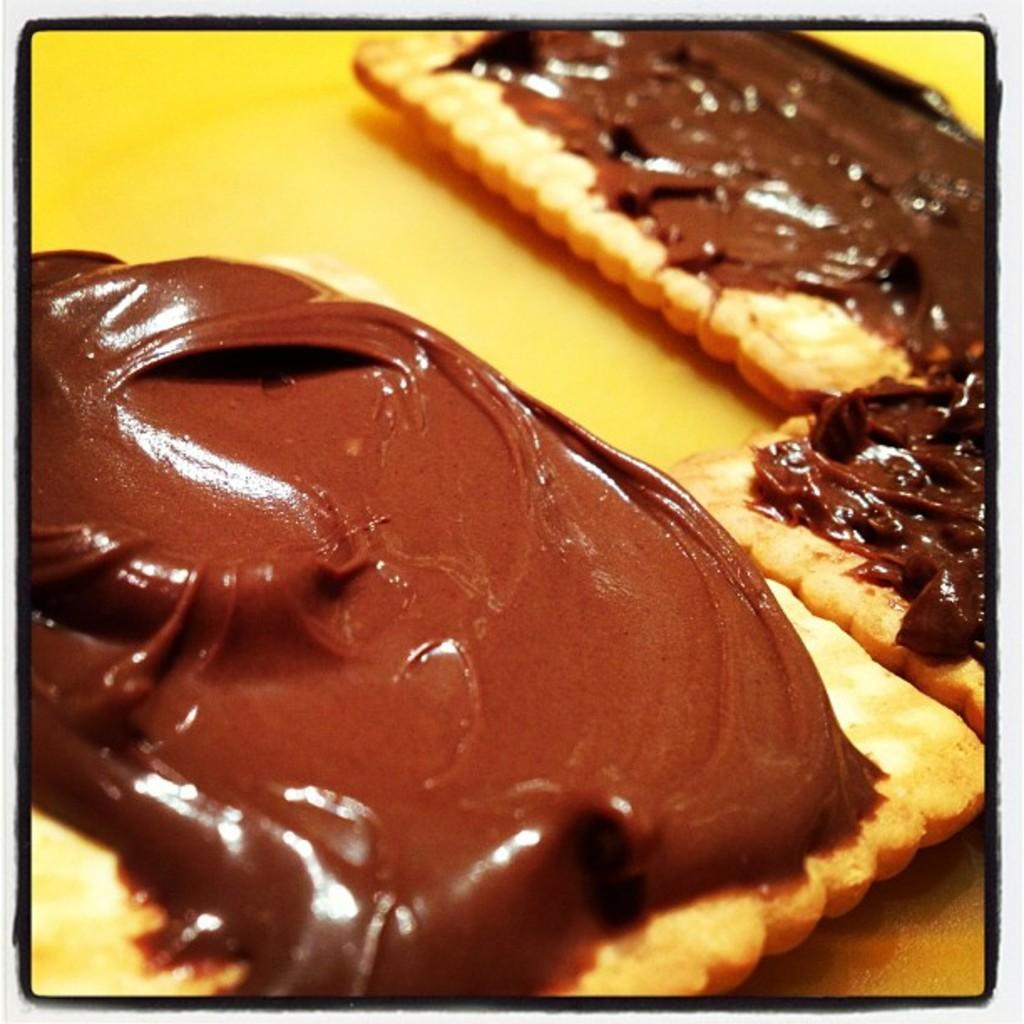How many biscuits are visible in the image? There are three biscuits in the image. What is on top of the biscuits? There is chocolate cream on the biscuits. What are the babies doing with the biscuits in the image? There are no babies present in the image, so it is not possible to answer that question. 